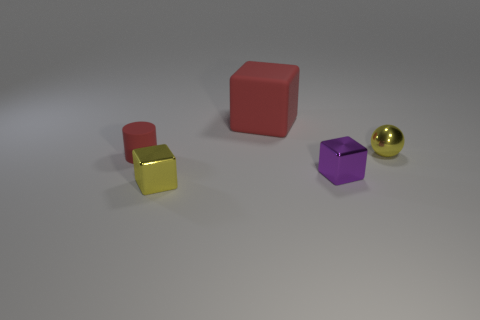Are there any other things that are the same size as the red rubber cube?
Make the answer very short. No. The red cube that is behind the small purple cube on the right side of the large red cube is made of what material?
Give a very brief answer. Rubber. Is the number of small cubes that are in front of the small yellow shiny block less than the number of yellow things that are behind the purple metal object?
Provide a succinct answer. Yes. What number of blue things are matte objects or cylinders?
Provide a succinct answer. 0. Is the number of small matte cylinders that are right of the metallic sphere the same as the number of tiny gray shiny spheres?
Offer a very short reply. Yes. How many things are either small purple blocks or red matte objects that are on the left side of the red rubber cube?
Offer a terse response. 2. Is the color of the small rubber thing the same as the large rubber thing?
Offer a terse response. Yes. Are there any blocks that have the same material as the small yellow sphere?
Provide a succinct answer. Yes. What color is the other rubber thing that is the same shape as the purple object?
Your answer should be compact. Red. Does the cylinder have the same material as the yellow thing behind the cylinder?
Provide a succinct answer. No. 